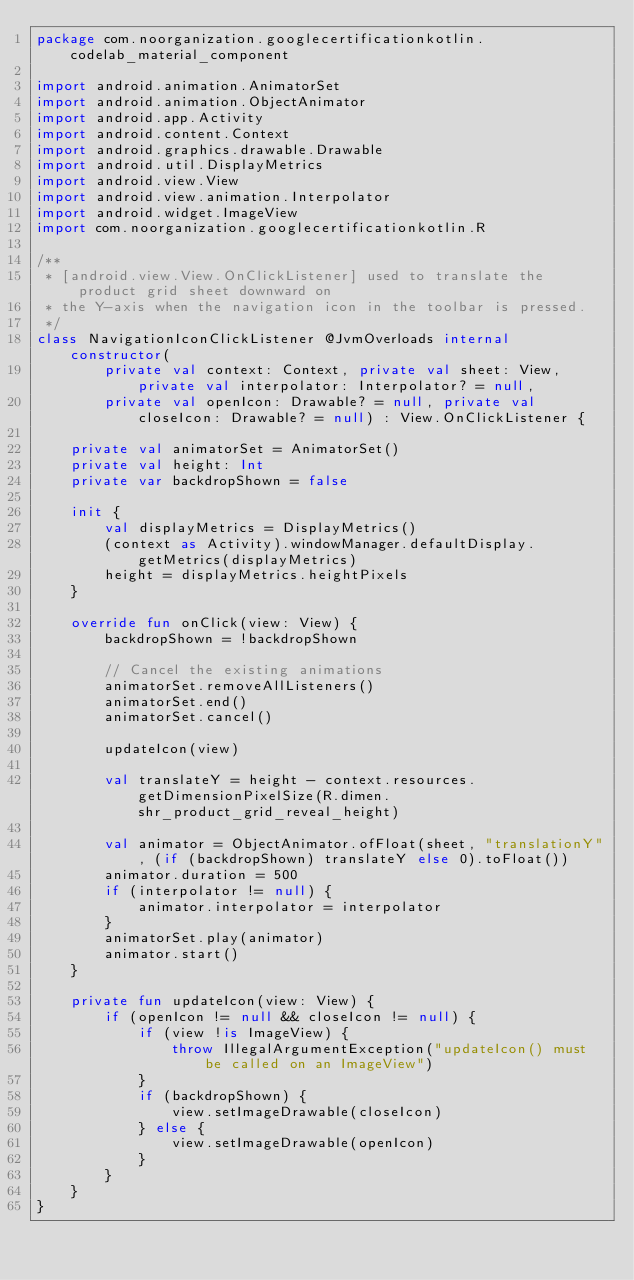Convert code to text. <code><loc_0><loc_0><loc_500><loc_500><_Kotlin_>package com.noorganization.googlecertificationkotlin.codelab_material_component

import android.animation.AnimatorSet
import android.animation.ObjectAnimator
import android.app.Activity
import android.content.Context
import android.graphics.drawable.Drawable
import android.util.DisplayMetrics
import android.view.View
import android.view.animation.Interpolator
import android.widget.ImageView
import com.noorganization.googlecertificationkotlin.R

/**
 * [android.view.View.OnClickListener] used to translate the product grid sheet downward on
 * the Y-axis when the navigation icon in the toolbar is pressed.
 */
class NavigationIconClickListener @JvmOverloads internal constructor(
        private val context: Context, private val sheet: View, private val interpolator: Interpolator? = null,
        private val openIcon: Drawable? = null, private val closeIcon: Drawable? = null) : View.OnClickListener {

    private val animatorSet = AnimatorSet()
    private val height: Int
    private var backdropShown = false

    init {
        val displayMetrics = DisplayMetrics()
        (context as Activity).windowManager.defaultDisplay.getMetrics(displayMetrics)
        height = displayMetrics.heightPixels
    }

    override fun onClick(view: View) {
        backdropShown = !backdropShown

        // Cancel the existing animations
        animatorSet.removeAllListeners()
        animatorSet.end()
        animatorSet.cancel()

        updateIcon(view)

        val translateY = height - context.resources.getDimensionPixelSize(R.dimen.shr_product_grid_reveal_height)

        val animator = ObjectAnimator.ofFloat(sheet, "translationY", (if (backdropShown) translateY else 0).toFloat())
        animator.duration = 500
        if (interpolator != null) {
            animator.interpolator = interpolator
        }
        animatorSet.play(animator)
        animator.start()
    }

    private fun updateIcon(view: View) {
        if (openIcon != null && closeIcon != null) {
            if (view !is ImageView) {
                throw IllegalArgumentException("updateIcon() must be called on an ImageView")
            }
            if (backdropShown) {
                view.setImageDrawable(closeIcon)
            } else {
                view.setImageDrawable(openIcon)
            }
        }
    }
}
</code> 